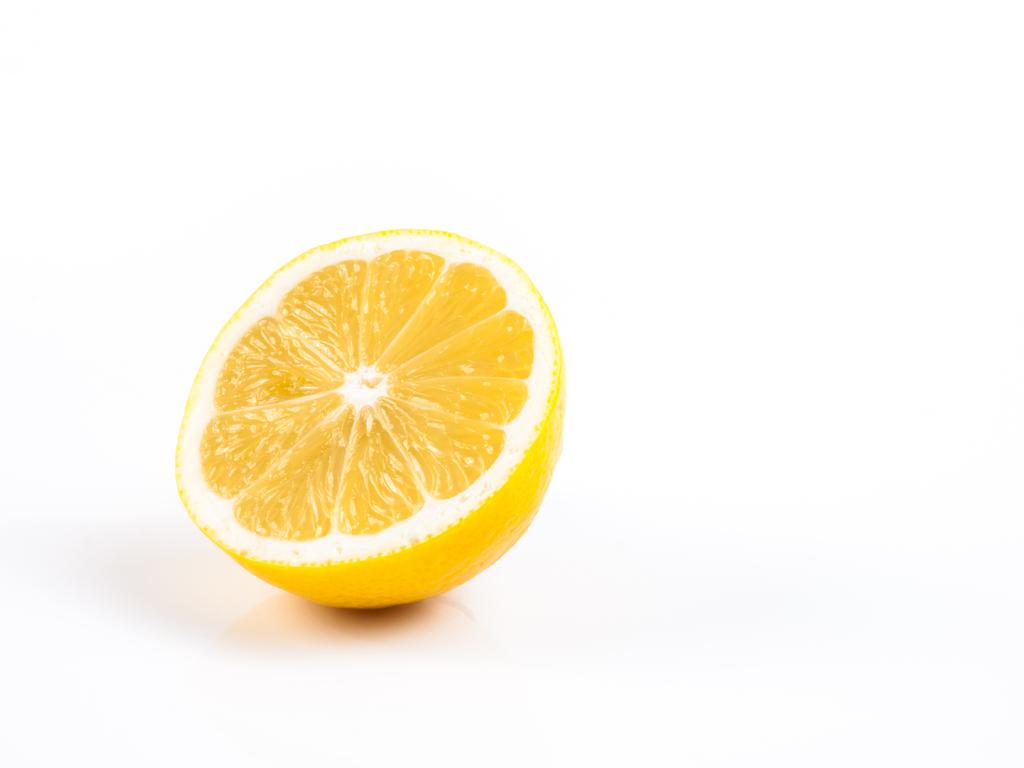What is present in the image that resembles a slice of a citrus fruit? There is a lemon slice in the image. What is the lemon slice placed on or near? The lemon slice is on an object. What type of clock is visible in the image? There is no clock present in the image; it only features a lemon slice on an object. How many clovers can be seen in the image? There are no clovers present in the image; it only features a lemon slice on an object. 